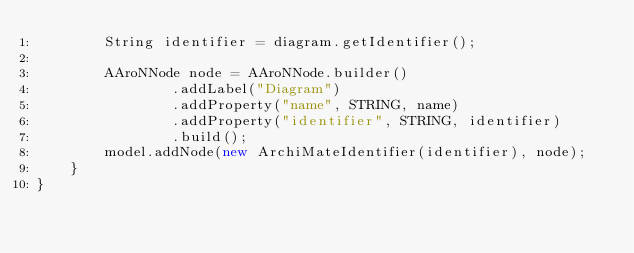<code> <loc_0><loc_0><loc_500><loc_500><_Java_>        String identifier = diagram.getIdentifier();

        AAroNNode node = AAroNNode.builder()
                .addLabel("Diagram")
                .addProperty("name", STRING, name)
                .addProperty("identifier", STRING, identifier)
                .build();
        model.addNode(new ArchiMateIdentifier(identifier), node);
    }
}
</code> 